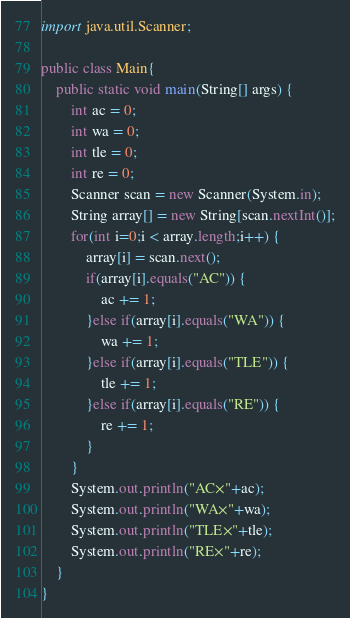<code> <loc_0><loc_0><loc_500><loc_500><_Java_>import java.util.Scanner;

public class Main{
	public static void main(String[] args) {
		int ac = 0;
		int wa = 0;
		int tle = 0;
		int re = 0;
		Scanner scan = new Scanner(System.in);
		String array[] = new String[scan.nextInt()];
		for(int i=0;i < array.length;i++) {
			array[i] = scan.next();
			if(array[i].equals("AC")) {
				ac += 1;
			}else if(array[i].equals("WA")) {
				wa += 1;
			}else if(array[i].equals("TLE")) {
				tle += 1;
			}else if(array[i].equals("RE")) {
				re += 1;
			}
		}
		System.out.println("AC×"+ac);
		System.out.println("WA×"+wa);
		System.out.println("TLE×"+tle);
		System.out.println("RE×"+re);
	}
}</code> 